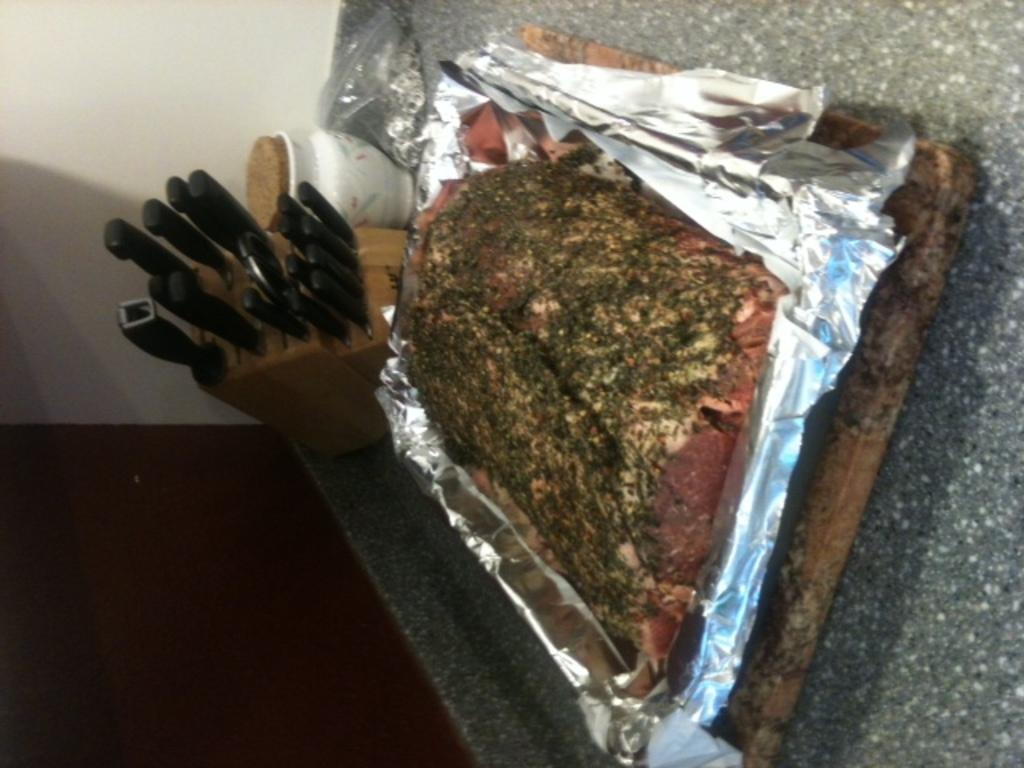In one or two sentences, can you explain what this image depicts? In the center of the image, we can see meat on the tray and in the background, there are knives and we can see a jar. At the bottom, there is a table. 